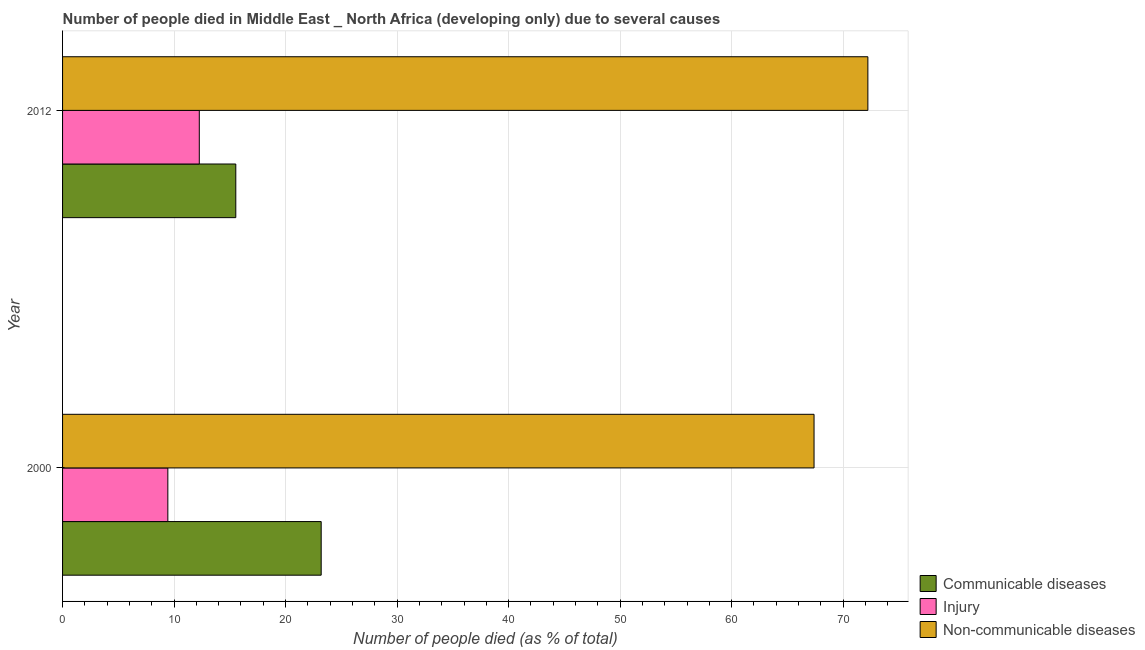How many groups of bars are there?
Your answer should be very brief. 2. Are the number of bars on each tick of the Y-axis equal?
Give a very brief answer. Yes. How many bars are there on the 2nd tick from the top?
Give a very brief answer. 3. How many bars are there on the 2nd tick from the bottom?
Provide a short and direct response. 3. What is the number of people who dies of non-communicable diseases in 2000?
Provide a succinct answer. 67.39. Across all years, what is the maximum number of people who dies of non-communicable diseases?
Your response must be concise. 72.22. Across all years, what is the minimum number of people who dies of non-communicable diseases?
Your answer should be compact. 67.39. In which year was the number of people who died of injury minimum?
Provide a succinct answer. 2000. What is the total number of people who died of communicable diseases in the graph?
Offer a very short reply. 38.73. What is the difference between the number of people who died of injury in 2000 and that in 2012?
Ensure brevity in your answer.  -2.82. What is the difference between the number of people who dies of non-communicable diseases in 2000 and the number of people who died of injury in 2012?
Your response must be concise. 55.13. What is the average number of people who died of injury per year?
Provide a short and direct response. 10.85. In the year 2012, what is the difference between the number of people who died of injury and number of people who died of communicable diseases?
Keep it short and to the point. -3.27. What is the ratio of the number of people who died of injury in 2000 to that in 2012?
Your response must be concise. 0.77. Is the difference between the number of people who died of injury in 2000 and 2012 greater than the difference between the number of people who died of communicable diseases in 2000 and 2012?
Provide a succinct answer. No. What does the 2nd bar from the top in 2000 represents?
Provide a succinct answer. Injury. What does the 3rd bar from the bottom in 2000 represents?
Ensure brevity in your answer.  Non-communicable diseases. How many bars are there?
Ensure brevity in your answer.  6. Does the graph contain grids?
Give a very brief answer. Yes. Where does the legend appear in the graph?
Make the answer very short. Bottom right. How many legend labels are there?
Ensure brevity in your answer.  3. How are the legend labels stacked?
Offer a terse response. Vertical. What is the title of the graph?
Offer a terse response. Number of people died in Middle East _ North Africa (developing only) due to several causes. Does "Ores and metals" appear as one of the legend labels in the graph?
Provide a succinct answer. No. What is the label or title of the X-axis?
Offer a terse response. Number of people died (as % of total). What is the Number of people died (as % of total) in Communicable diseases in 2000?
Provide a succinct answer. 23.19. What is the Number of people died (as % of total) in Injury in 2000?
Your answer should be very brief. 9.44. What is the Number of people died (as % of total) in Non-communicable diseases in 2000?
Your response must be concise. 67.39. What is the Number of people died (as % of total) of Communicable diseases in 2012?
Provide a succinct answer. 15.54. What is the Number of people died (as % of total) in Injury in 2012?
Your response must be concise. 12.26. What is the Number of people died (as % of total) of Non-communicable diseases in 2012?
Provide a short and direct response. 72.22. Across all years, what is the maximum Number of people died (as % of total) in Communicable diseases?
Your response must be concise. 23.19. Across all years, what is the maximum Number of people died (as % of total) in Injury?
Give a very brief answer. 12.26. Across all years, what is the maximum Number of people died (as % of total) in Non-communicable diseases?
Make the answer very short. 72.22. Across all years, what is the minimum Number of people died (as % of total) of Communicable diseases?
Keep it short and to the point. 15.54. Across all years, what is the minimum Number of people died (as % of total) in Injury?
Your answer should be very brief. 9.44. Across all years, what is the minimum Number of people died (as % of total) in Non-communicable diseases?
Your response must be concise. 67.39. What is the total Number of people died (as % of total) of Communicable diseases in the graph?
Offer a very short reply. 38.73. What is the total Number of people died (as % of total) of Injury in the graph?
Your response must be concise. 21.7. What is the total Number of people died (as % of total) of Non-communicable diseases in the graph?
Provide a succinct answer. 139.61. What is the difference between the Number of people died (as % of total) in Communicable diseases in 2000 and that in 2012?
Provide a succinct answer. 7.66. What is the difference between the Number of people died (as % of total) of Injury in 2000 and that in 2012?
Your answer should be compact. -2.82. What is the difference between the Number of people died (as % of total) of Non-communicable diseases in 2000 and that in 2012?
Offer a terse response. -4.83. What is the difference between the Number of people died (as % of total) in Communicable diseases in 2000 and the Number of people died (as % of total) in Injury in 2012?
Ensure brevity in your answer.  10.93. What is the difference between the Number of people died (as % of total) in Communicable diseases in 2000 and the Number of people died (as % of total) in Non-communicable diseases in 2012?
Offer a terse response. -49.03. What is the difference between the Number of people died (as % of total) in Injury in 2000 and the Number of people died (as % of total) in Non-communicable diseases in 2012?
Ensure brevity in your answer.  -62.78. What is the average Number of people died (as % of total) of Communicable diseases per year?
Your answer should be compact. 19.36. What is the average Number of people died (as % of total) in Injury per year?
Keep it short and to the point. 10.85. What is the average Number of people died (as % of total) of Non-communicable diseases per year?
Give a very brief answer. 69.8. In the year 2000, what is the difference between the Number of people died (as % of total) in Communicable diseases and Number of people died (as % of total) in Injury?
Your answer should be compact. 13.75. In the year 2000, what is the difference between the Number of people died (as % of total) in Communicable diseases and Number of people died (as % of total) in Non-communicable diseases?
Your response must be concise. -44.2. In the year 2000, what is the difference between the Number of people died (as % of total) of Injury and Number of people died (as % of total) of Non-communicable diseases?
Provide a short and direct response. -57.95. In the year 2012, what is the difference between the Number of people died (as % of total) of Communicable diseases and Number of people died (as % of total) of Injury?
Provide a short and direct response. 3.27. In the year 2012, what is the difference between the Number of people died (as % of total) in Communicable diseases and Number of people died (as % of total) in Non-communicable diseases?
Give a very brief answer. -56.68. In the year 2012, what is the difference between the Number of people died (as % of total) of Injury and Number of people died (as % of total) of Non-communicable diseases?
Your answer should be compact. -59.96. What is the ratio of the Number of people died (as % of total) in Communicable diseases in 2000 to that in 2012?
Make the answer very short. 1.49. What is the ratio of the Number of people died (as % of total) in Injury in 2000 to that in 2012?
Offer a very short reply. 0.77. What is the ratio of the Number of people died (as % of total) in Non-communicable diseases in 2000 to that in 2012?
Keep it short and to the point. 0.93. What is the difference between the highest and the second highest Number of people died (as % of total) of Communicable diseases?
Your answer should be very brief. 7.66. What is the difference between the highest and the second highest Number of people died (as % of total) of Injury?
Make the answer very short. 2.82. What is the difference between the highest and the second highest Number of people died (as % of total) of Non-communicable diseases?
Make the answer very short. 4.83. What is the difference between the highest and the lowest Number of people died (as % of total) of Communicable diseases?
Your answer should be very brief. 7.66. What is the difference between the highest and the lowest Number of people died (as % of total) in Injury?
Provide a succinct answer. 2.82. What is the difference between the highest and the lowest Number of people died (as % of total) in Non-communicable diseases?
Offer a very short reply. 4.83. 